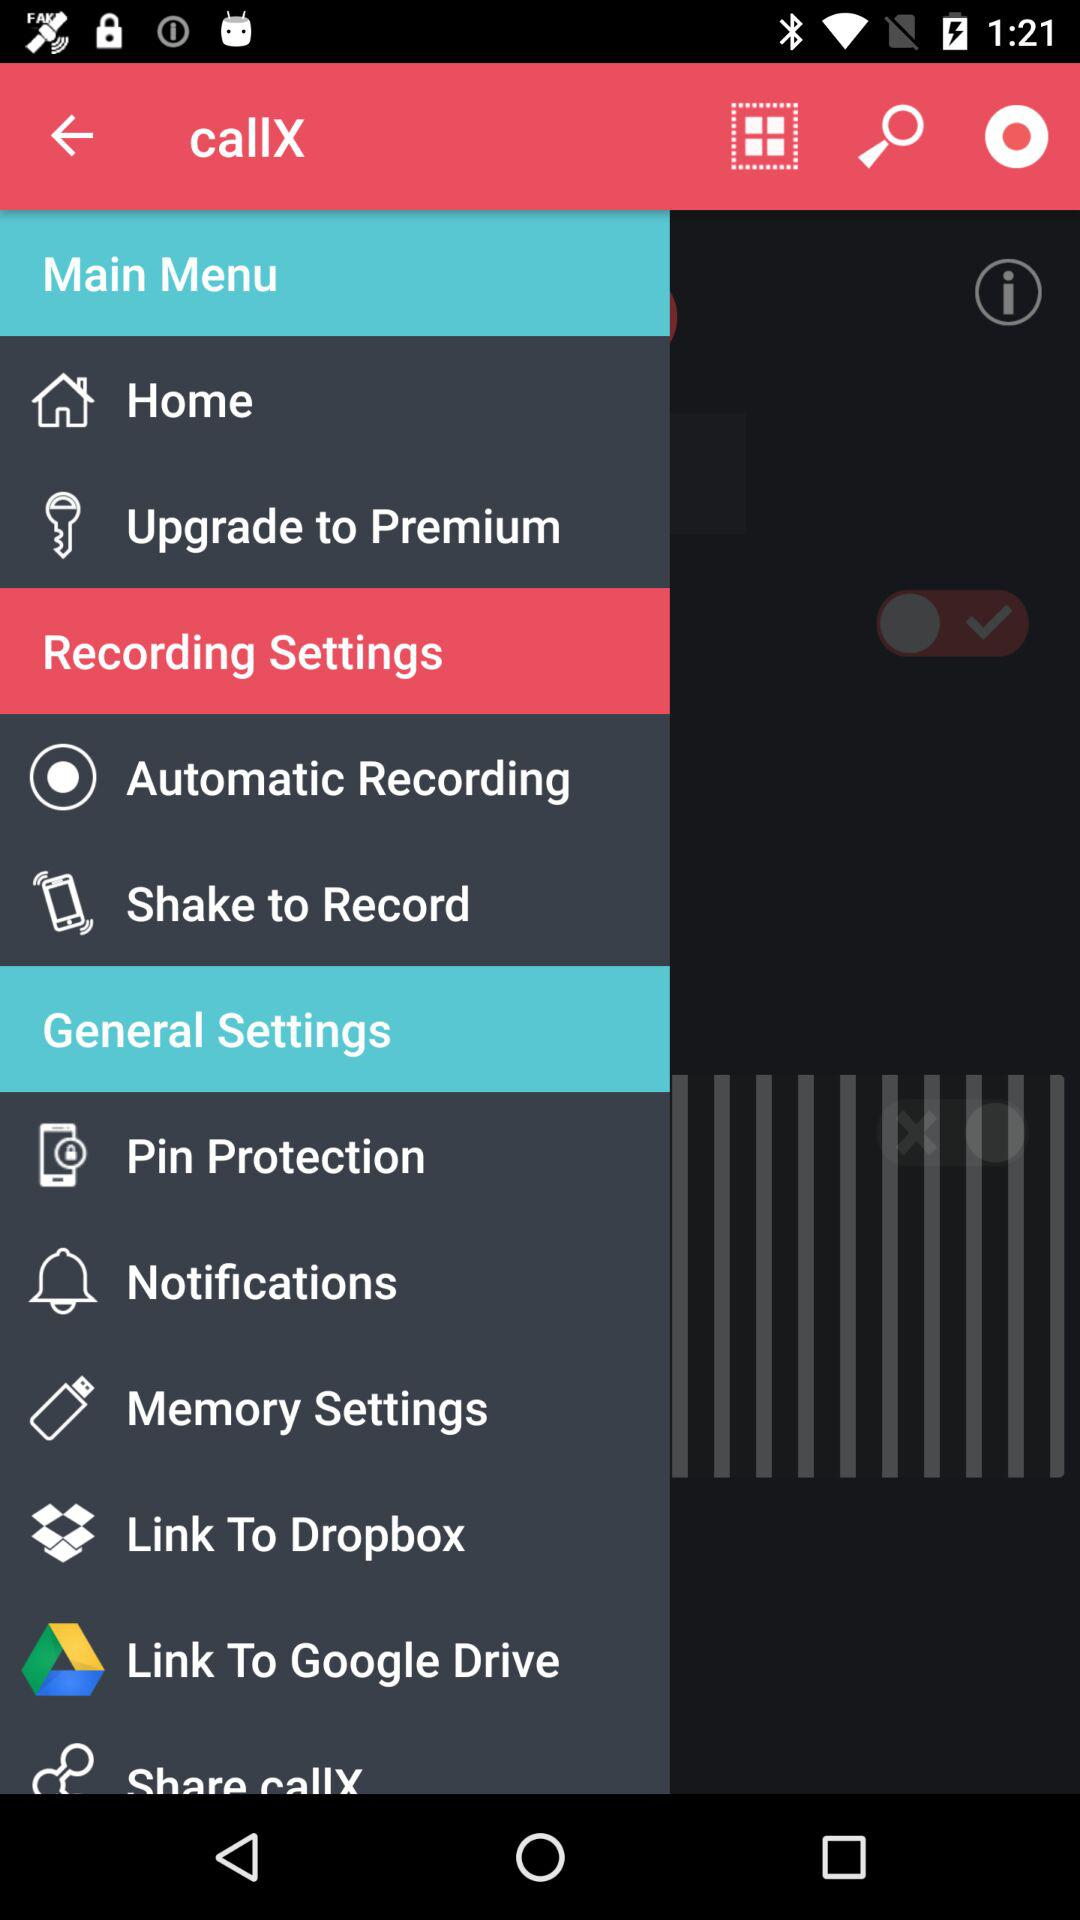What is the application name? The application name is "callX". 